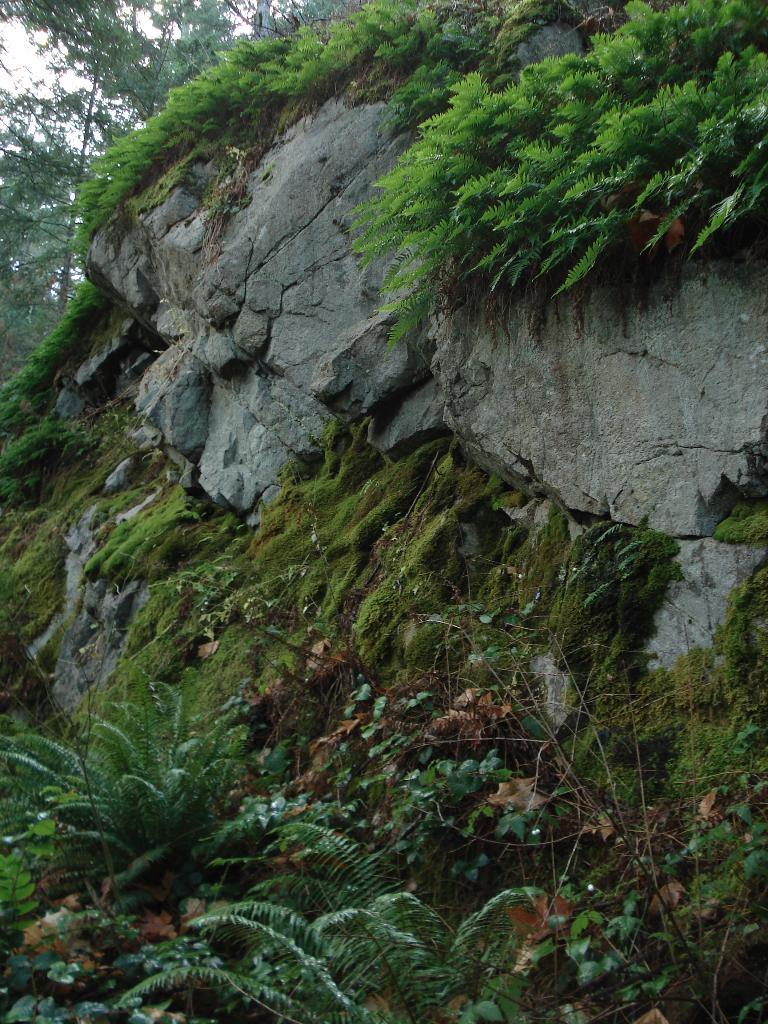What is the main subject of the image? The main subject of the image is a rock. What is growing on the rock? Grass and plants are present on the rock. Are there any plants visible at the bottom of the image? Yes, there are plants at the bottom of the image. What can be seen in the left top area of the image? There are trees in the left top area of the image. What type of fiction is being read by the person standing on the street in the image? There is no person or street present in the image; it features a rock with grass and plants. 